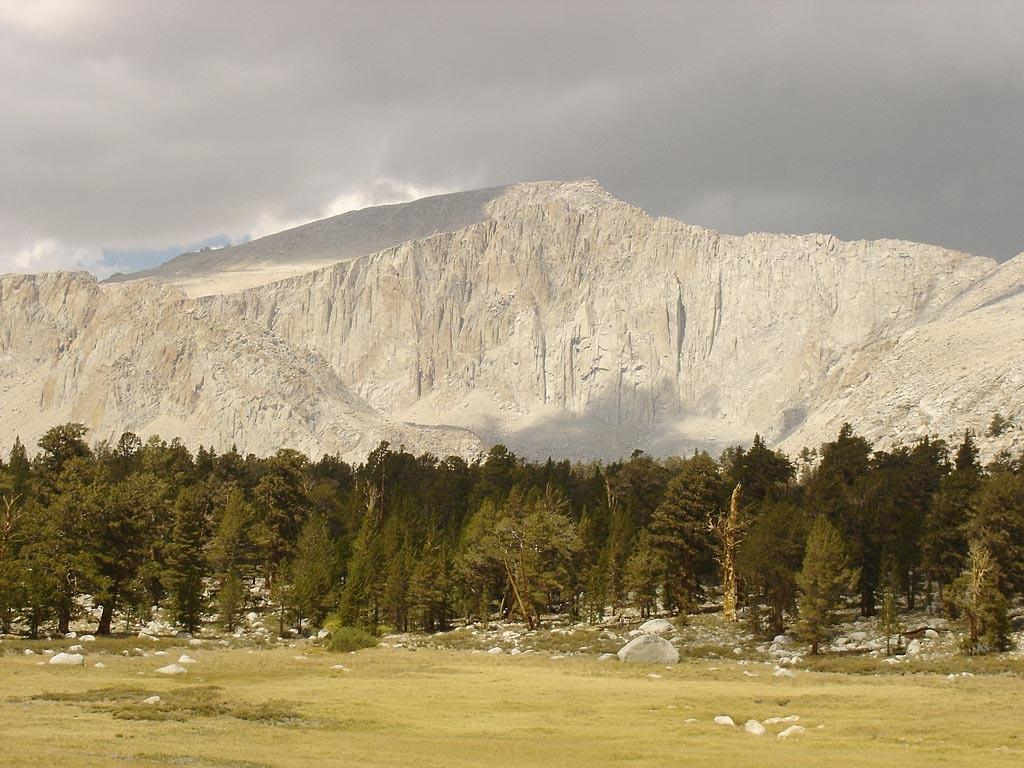What type of vegetation is present in the image? There are trees in the image. What type of ground cover is present in the image? There is grass in the image. What type of geological formation is present in the image? There are rocks in the image. What can be seen in the background of the image? There is a hill in the background of the image. What is visible in the sky in the image? The sky is visible in the background of the image, and it is cloudy. Can you tell me how many robins are perched on the trees in the image? There are no robins present in the image; it only features trees, grass, rocks, a hill, and a cloudy sky. Is there a girl playing on the hill in the image? There is no girl present in the image. 